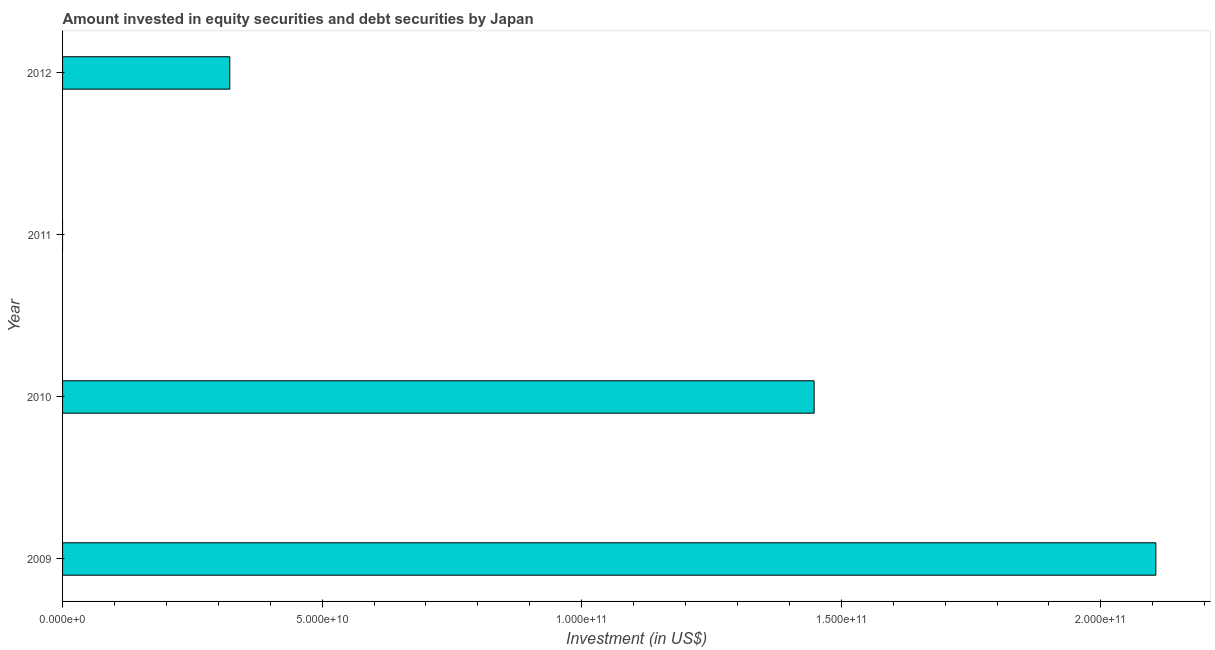Does the graph contain any zero values?
Ensure brevity in your answer.  Yes. Does the graph contain grids?
Give a very brief answer. No. What is the title of the graph?
Keep it short and to the point. Amount invested in equity securities and debt securities by Japan. What is the label or title of the X-axis?
Make the answer very short. Investment (in US$). What is the portfolio investment in 2011?
Give a very brief answer. 0. Across all years, what is the maximum portfolio investment?
Ensure brevity in your answer.  2.11e+11. In which year was the portfolio investment maximum?
Keep it short and to the point. 2009. What is the sum of the portfolio investment?
Offer a terse response. 3.88e+11. What is the difference between the portfolio investment in 2009 and 2012?
Offer a very short reply. 1.78e+11. What is the average portfolio investment per year?
Keep it short and to the point. 9.69e+1. What is the median portfolio investment?
Your response must be concise. 8.85e+1. In how many years, is the portfolio investment greater than 10000000000 US$?
Offer a terse response. 3. What is the ratio of the portfolio investment in 2009 to that in 2012?
Your response must be concise. 6.54. Is the portfolio investment in 2009 less than that in 2012?
Ensure brevity in your answer.  No. What is the difference between the highest and the second highest portfolio investment?
Offer a terse response. 6.58e+1. Is the sum of the portfolio investment in 2010 and 2012 greater than the maximum portfolio investment across all years?
Provide a succinct answer. No. What is the difference between the highest and the lowest portfolio investment?
Your answer should be very brief. 2.11e+11. In how many years, is the portfolio investment greater than the average portfolio investment taken over all years?
Your answer should be very brief. 2. What is the difference between two consecutive major ticks on the X-axis?
Provide a short and direct response. 5.00e+1. What is the Investment (in US$) of 2009?
Offer a very short reply. 2.11e+11. What is the Investment (in US$) in 2010?
Ensure brevity in your answer.  1.45e+11. What is the Investment (in US$) in 2012?
Provide a short and direct response. 3.22e+1. What is the difference between the Investment (in US$) in 2009 and 2010?
Provide a short and direct response. 6.58e+1. What is the difference between the Investment (in US$) in 2009 and 2012?
Offer a terse response. 1.78e+11. What is the difference between the Investment (in US$) in 2010 and 2012?
Your answer should be compact. 1.13e+11. What is the ratio of the Investment (in US$) in 2009 to that in 2010?
Give a very brief answer. 1.46. What is the ratio of the Investment (in US$) in 2009 to that in 2012?
Offer a terse response. 6.54. What is the ratio of the Investment (in US$) in 2010 to that in 2012?
Give a very brief answer. 4.49. 